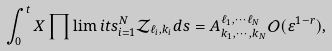Convert formula to latex. <formula><loc_0><loc_0><loc_500><loc_500>\int _ { 0 } ^ { t } X \prod \lim i t s _ { i = 1 } ^ { N } \mathcal { Z } _ { \ell _ { i } , k _ { i } } d s = A _ { k _ { 1 } , \cdots , k _ { N } } ^ { \ell _ { 1 } , \cdots \ell _ { N } } \mathcal { O } ( \varepsilon ^ { 1 - r } ) ,</formula> 